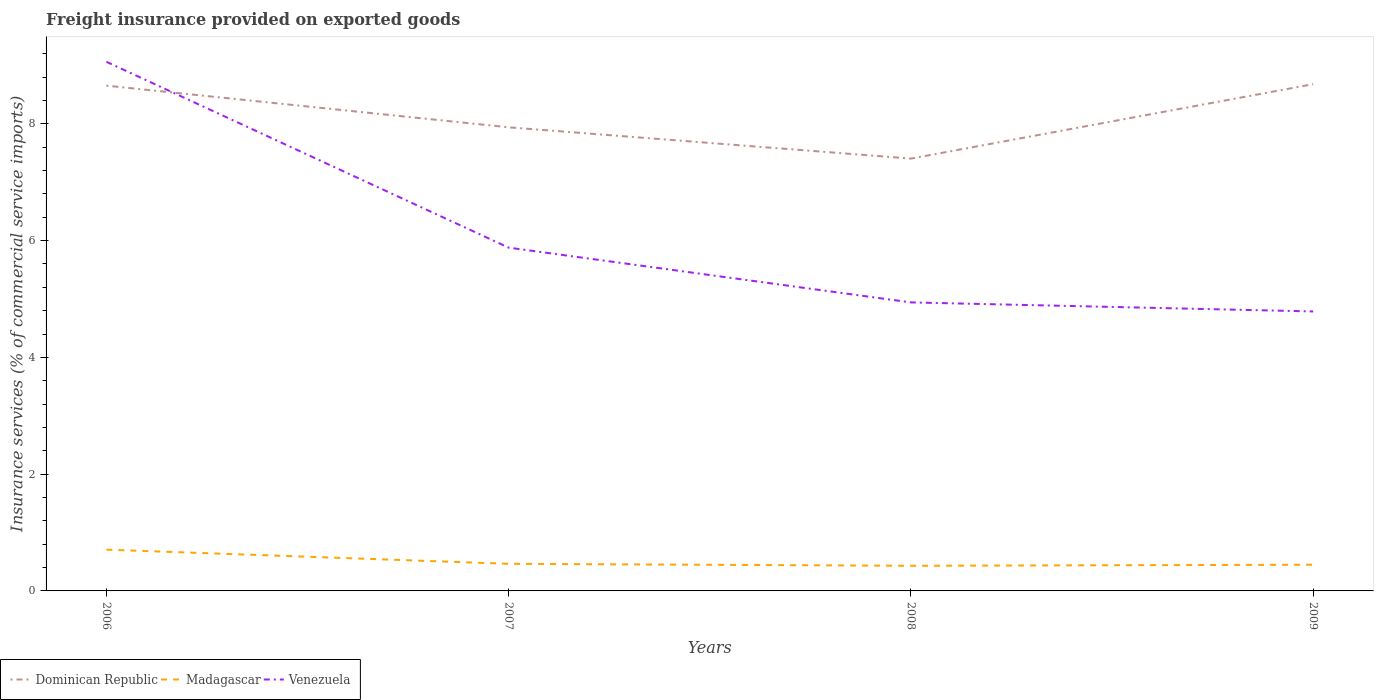How many different coloured lines are there?
Ensure brevity in your answer.  3. Across all years, what is the maximum freight insurance provided on exported goods in Dominican Republic?
Make the answer very short. 7.4. In which year was the freight insurance provided on exported goods in Venezuela maximum?
Make the answer very short. 2009. What is the total freight insurance provided on exported goods in Venezuela in the graph?
Ensure brevity in your answer.  0.15. What is the difference between the highest and the second highest freight insurance provided on exported goods in Dominican Republic?
Offer a very short reply. 1.27. Does the graph contain grids?
Provide a short and direct response. No. Where does the legend appear in the graph?
Give a very brief answer. Bottom left. How are the legend labels stacked?
Offer a terse response. Horizontal. What is the title of the graph?
Give a very brief answer. Freight insurance provided on exported goods. What is the label or title of the X-axis?
Your response must be concise. Years. What is the label or title of the Y-axis?
Your response must be concise. Insurance services (% of commercial service imports). What is the Insurance services (% of commercial service imports) in Dominican Republic in 2006?
Provide a succinct answer. 8.65. What is the Insurance services (% of commercial service imports) of Madagascar in 2006?
Your response must be concise. 0.71. What is the Insurance services (% of commercial service imports) in Venezuela in 2006?
Provide a succinct answer. 9.06. What is the Insurance services (% of commercial service imports) of Dominican Republic in 2007?
Ensure brevity in your answer.  7.94. What is the Insurance services (% of commercial service imports) of Madagascar in 2007?
Your response must be concise. 0.46. What is the Insurance services (% of commercial service imports) of Venezuela in 2007?
Offer a terse response. 5.88. What is the Insurance services (% of commercial service imports) of Dominican Republic in 2008?
Your answer should be very brief. 7.4. What is the Insurance services (% of commercial service imports) in Madagascar in 2008?
Keep it short and to the point. 0.43. What is the Insurance services (% of commercial service imports) of Venezuela in 2008?
Ensure brevity in your answer.  4.94. What is the Insurance services (% of commercial service imports) in Dominican Republic in 2009?
Offer a very short reply. 8.68. What is the Insurance services (% of commercial service imports) of Madagascar in 2009?
Make the answer very short. 0.45. What is the Insurance services (% of commercial service imports) of Venezuela in 2009?
Provide a short and direct response. 4.79. Across all years, what is the maximum Insurance services (% of commercial service imports) in Dominican Republic?
Offer a terse response. 8.68. Across all years, what is the maximum Insurance services (% of commercial service imports) in Madagascar?
Your answer should be compact. 0.71. Across all years, what is the maximum Insurance services (% of commercial service imports) of Venezuela?
Offer a very short reply. 9.06. Across all years, what is the minimum Insurance services (% of commercial service imports) of Dominican Republic?
Your response must be concise. 7.4. Across all years, what is the minimum Insurance services (% of commercial service imports) of Madagascar?
Give a very brief answer. 0.43. Across all years, what is the minimum Insurance services (% of commercial service imports) in Venezuela?
Your answer should be very brief. 4.79. What is the total Insurance services (% of commercial service imports) in Dominican Republic in the graph?
Your response must be concise. 32.68. What is the total Insurance services (% of commercial service imports) in Madagascar in the graph?
Your answer should be compact. 2.05. What is the total Insurance services (% of commercial service imports) in Venezuela in the graph?
Your answer should be very brief. 24.67. What is the difference between the Insurance services (% of commercial service imports) of Dominican Republic in 2006 and that in 2007?
Provide a short and direct response. 0.71. What is the difference between the Insurance services (% of commercial service imports) in Madagascar in 2006 and that in 2007?
Your answer should be very brief. 0.24. What is the difference between the Insurance services (% of commercial service imports) of Venezuela in 2006 and that in 2007?
Provide a succinct answer. 3.18. What is the difference between the Insurance services (% of commercial service imports) in Dominican Republic in 2006 and that in 2008?
Your answer should be compact. 1.25. What is the difference between the Insurance services (% of commercial service imports) in Madagascar in 2006 and that in 2008?
Ensure brevity in your answer.  0.28. What is the difference between the Insurance services (% of commercial service imports) of Venezuela in 2006 and that in 2008?
Offer a very short reply. 4.12. What is the difference between the Insurance services (% of commercial service imports) in Dominican Republic in 2006 and that in 2009?
Offer a terse response. -0.03. What is the difference between the Insurance services (% of commercial service imports) of Madagascar in 2006 and that in 2009?
Provide a succinct answer. 0.26. What is the difference between the Insurance services (% of commercial service imports) of Venezuela in 2006 and that in 2009?
Your answer should be very brief. 4.28. What is the difference between the Insurance services (% of commercial service imports) in Dominican Republic in 2007 and that in 2008?
Your answer should be compact. 0.54. What is the difference between the Insurance services (% of commercial service imports) in Madagascar in 2007 and that in 2008?
Ensure brevity in your answer.  0.03. What is the difference between the Insurance services (% of commercial service imports) in Venezuela in 2007 and that in 2008?
Provide a short and direct response. 0.94. What is the difference between the Insurance services (% of commercial service imports) in Dominican Republic in 2007 and that in 2009?
Your response must be concise. -0.74. What is the difference between the Insurance services (% of commercial service imports) in Madagascar in 2007 and that in 2009?
Your answer should be compact. 0.02. What is the difference between the Insurance services (% of commercial service imports) in Venezuela in 2007 and that in 2009?
Provide a short and direct response. 1.09. What is the difference between the Insurance services (% of commercial service imports) of Dominican Republic in 2008 and that in 2009?
Your response must be concise. -1.27. What is the difference between the Insurance services (% of commercial service imports) of Madagascar in 2008 and that in 2009?
Your answer should be very brief. -0.02. What is the difference between the Insurance services (% of commercial service imports) of Venezuela in 2008 and that in 2009?
Make the answer very short. 0.15. What is the difference between the Insurance services (% of commercial service imports) in Dominican Republic in 2006 and the Insurance services (% of commercial service imports) in Madagascar in 2007?
Give a very brief answer. 8.19. What is the difference between the Insurance services (% of commercial service imports) of Dominican Republic in 2006 and the Insurance services (% of commercial service imports) of Venezuela in 2007?
Your answer should be very brief. 2.77. What is the difference between the Insurance services (% of commercial service imports) in Madagascar in 2006 and the Insurance services (% of commercial service imports) in Venezuela in 2007?
Provide a short and direct response. -5.17. What is the difference between the Insurance services (% of commercial service imports) of Dominican Republic in 2006 and the Insurance services (% of commercial service imports) of Madagascar in 2008?
Provide a succinct answer. 8.22. What is the difference between the Insurance services (% of commercial service imports) in Dominican Republic in 2006 and the Insurance services (% of commercial service imports) in Venezuela in 2008?
Ensure brevity in your answer.  3.71. What is the difference between the Insurance services (% of commercial service imports) in Madagascar in 2006 and the Insurance services (% of commercial service imports) in Venezuela in 2008?
Provide a succinct answer. -4.23. What is the difference between the Insurance services (% of commercial service imports) in Dominican Republic in 2006 and the Insurance services (% of commercial service imports) in Madagascar in 2009?
Make the answer very short. 8.21. What is the difference between the Insurance services (% of commercial service imports) of Dominican Republic in 2006 and the Insurance services (% of commercial service imports) of Venezuela in 2009?
Ensure brevity in your answer.  3.87. What is the difference between the Insurance services (% of commercial service imports) in Madagascar in 2006 and the Insurance services (% of commercial service imports) in Venezuela in 2009?
Provide a short and direct response. -4.08. What is the difference between the Insurance services (% of commercial service imports) in Dominican Republic in 2007 and the Insurance services (% of commercial service imports) in Madagascar in 2008?
Your answer should be compact. 7.51. What is the difference between the Insurance services (% of commercial service imports) in Dominican Republic in 2007 and the Insurance services (% of commercial service imports) in Venezuela in 2008?
Provide a succinct answer. 3. What is the difference between the Insurance services (% of commercial service imports) in Madagascar in 2007 and the Insurance services (% of commercial service imports) in Venezuela in 2008?
Provide a short and direct response. -4.48. What is the difference between the Insurance services (% of commercial service imports) of Dominican Republic in 2007 and the Insurance services (% of commercial service imports) of Madagascar in 2009?
Your answer should be very brief. 7.49. What is the difference between the Insurance services (% of commercial service imports) in Dominican Republic in 2007 and the Insurance services (% of commercial service imports) in Venezuela in 2009?
Make the answer very short. 3.15. What is the difference between the Insurance services (% of commercial service imports) of Madagascar in 2007 and the Insurance services (% of commercial service imports) of Venezuela in 2009?
Give a very brief answer. -4.32. What is the difference between the Insurance services (% of commercial service imports) in Dominican Republic in 2008 and the Insurance services (% of commercial service imports) in Madagascar in 2009?
Offer a very short reply. 6.96. What is the difference between the Insurance services (% of commercial service imports) of Dominican Republic in 2008 and the Insurance services (% of commercial service imports) of Venezuela in 2009?
Give a very brief answer. 2.62. What is the difference between the Insurance services (% of commercial service imports) in Madagascar in 2008 and the Insurance services (% of commercial service imports) in Venezuela in 2009?
Offer a terse response. -4.36. What is the average Insurance services (% of commercial service imports) of Dominican Republic per year?
Your answer should be compact. 8.17. What is the average Insurance services (% of commercial service imports) of Madagascar per year?
Offer a terse response. 0.51. What is the average Insurance services (% of commercial service imports) of Venezuela per year?
Ensure brevity in your answer.  6.17. In the year 2006, what is the difference between the Insurance services (% of commercial service imports) of Dominican Republic and Insurance services (% of commercial service imports) of Madagascar?
Your answer should be very brief. 7.95. In the year 2006, what is the difference between the Insurance services (% of commercial service imports) in Dominican Republic and Insurance services (% of commercial service imports) in Venezuela?
Offer a very short reply. -0.41. In the year 2006, what is the difference between the Insurance services (% of commercial service imports) of Madagascar and Insurance services (% of commercial service imports) of Venezuela?
Your response must be concise. -8.36. In the year 2007, what is the difference between the Insurance services (% of commercial service imports) in Dominican Republic and Insurance services (% of commercial service imports) in Madagascar?
Provide a short and direct response. 7.48. In the year 2007, what is the difference between the Insurance services (% of commercial service imports) of Dominican Republic and Insurance services (% of commercial service imports) of Venezuela?
Your response must be concise. 2.06. In the year 2007, what is the difference between the Insurance services (% of commercial service imports) in Madagascar and Insurance services (% of commercial service imports) in Venezuela?
Offer a terse response. -5.42. In the year 2008, what is the difference between the Insurance services (% of commercial service imports) of Dominican Republic and Insurance services (% of commercial service imports) of Madagascar?
Make the answer very short. 6.97. In the year 2008, what is the difference between the Insurance services (% of commercial service imports) in Dominican Republic and Insurance services (% of commercial service imports) in Venezuela?
Offer a very short reply. 2.46. In the year 2008, what is the difference between the Insurance services (% of commercial service imports) of Madagascar and Insurance services (% of commercial service imports) of Venezuela?
Keep it short and to the point. -4.51. In the year 2009, what is the difference between the Insurance services (% of commercial service imports) of Dominican Republic and Insurance services (% of commercial service imports) of Madagascar?
Make the answer very short. 8.23. In the year 2009, what is the difference between the Insurance services (% of commercial service imports) of Dominican Republic and Insurance services (% of commercial service imports) of Venezuela?
Provide a short and direct response. 3.89. In the year 2009, what is the difference between the Insurance services (% of commercial service imports) in Madagascar and Insurance services (% of commercial service imports) in Venezuela?
Your answer should be very brief. -4.34. What is the ratio of the Insurance services (% of commercial service imports) in Dominican Republic in 2006 to that in 2007?
Make the answer very short. 1.09. What is the ratio of the Insurance services (% of commercial service imports) of Madagascar in 2006 to that in 2007?
Your answer should be compact. 1.52. What is the ratio of the Insurance services (% of commercial service imports) of Venezuela in 2006 to that in 2007?
Your answer should be very brief. 1.54. What is the ratio of the Insurance services (% of commercial service imports) of Dominican Republic in 2006 to that in 2008?
Offer a terse response. 1.17. What is the ratio of the Insurance services (% of commercial service imports) in Madagascar in 2006 to that in 2008?
Make the answer very short. 1.64. What is the ratio of the Insurance services (% of commercial service imports) in Venezuela in 2006 to that in 2008?
Give a very brief answer. 1.83. What is the ratio of the Insurance services (% of commercial service imports) in Dominican Republic in 2006 to that in 2009?
Provide a short and direct response. 1. What is the ratio of the Insurance services (% of commercial service imports) of Madagascar in 2006 to that in 2009?
Give a very brief answer. 1.58. What is the ratio of the Insurance services (% of commercial service imports) of Venezuela in 2006 to that in 2009?
Ensure brevity in your answer.  1.89. What is the ratio of the Insurance services (% of commercial service imports) of Dominican Republic in 2007 to that in 2008?
Your response must be concise. 1.07. What is the ratio of the Insurance services (% of commercial service imports) in Madagascar in 2007 to that in 2008?
Keep it short and to the point. 1.08. What is the ratio of the Insurance services (% of commercial service imports) in Venezuela in 2007 to that in 2008?
Ensure brevity in your answer.  1.19. What is the ratio of the Insurance services (% of commercial service imports) of Dominican Republic in 2007 to that in 2009?
Give a very brief answer. 0.91. What is the ratio of the Insurance services (% of commercial service imports) in Madagascar in 2007 to that in 2009?
Give a very brief answer. 1.04. What is the ratio of the Insurance services (% of commercial service imports) of Venezuela in 2007 to that in 2009?
Your answer should be compact. 1.23. What is the ratio of the Insurance services (% of commercial service imports) in Dominican Republic in 2008 to that in 2009?
Provide a short and direct response. 0.85. What is the ratio of the Insurance services (% of commercial service imports) of Madagascar in 2008 to that in 2009?
Your response must be concise. 0.96. What is the ratio of the Insurance services (% of commercial service imports) of Venezuela in 2008 to that in 2009?
Make the answer very short. 1.03. What is the difference between the highest and the second highest Insurance services (% of commercial service imports) of Dominican Republic?
Ensure brevity in your answer.  0.03. What is the difference between the highest and the second highest Insurance services (% of commercial service imports) of Madagascar?
Ensure brevity in your answer.  0.24. What is the difference between the highest and the second highest Insurance services (% of commercial service imports) of Venezuela?
Provide a short and direct response. 3.18. What is the difference between the highest and the lowest Insurance services (% of commercial service imports) of Dominican Republic?
Provide a succinct answer. 1.27. What is the difference between the highest and the lowest Insurance services (% of commercial service imports) in Madagascar?
Ensure brevity in your answer.  0.28. What is the difference between the highest and the lowest Insurance services (% of commercial service imports) in Venezuela?
Keep it short and to the point. 4.28. 